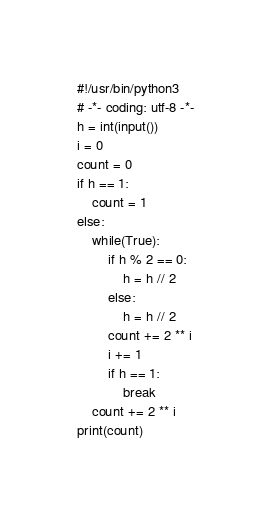<code> <loc_0><loc_0><loc_500><loc_500><_Python_>#!/usr/bin/python3
# -*- coding: utf-8 -*-
h = int(input())
i = 0
count = 0
if h == 1:
    count = 1
else:
    while(True):
        if h % 2 == 0:
            h = h // 2
        else:
            h = h // 2
        count += 2 ** i
        i += 1
        if h == 1:
            break
    count += 2 ** i
print(count)</code> 